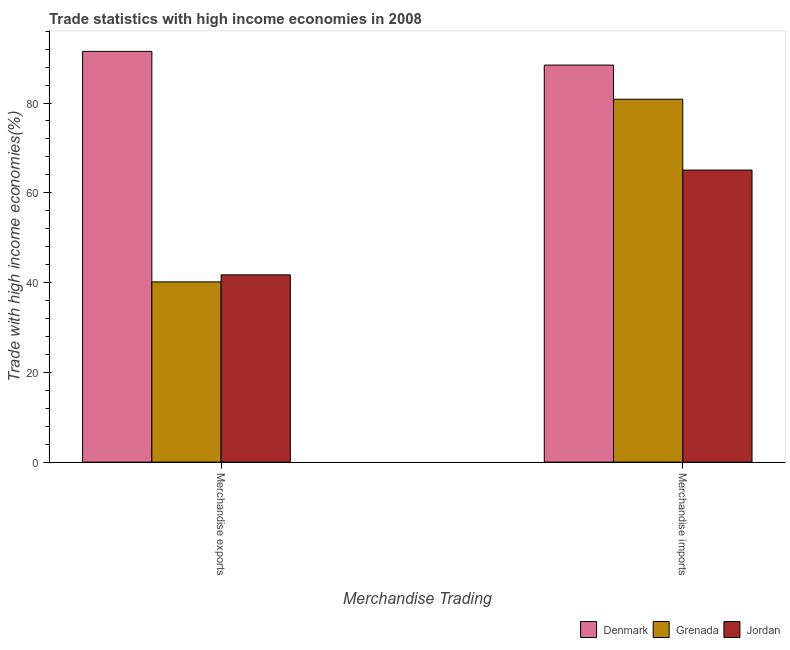Are the number of bars per tick equal to the number of legend labels?
Your answer should be compact. Yes. How many bars are there on the 2nd tick from the left?
Your response must be concise. 3. What is the merchandise imports in Jordan?
Offer a very short reply. 65.06. Across all countries, what is the maximum merchandise exports?
Provide a short and direct response. 91.5. Across all countries, what is the minimum merchandise imports?
Make the answer very short. 65.06. In which country was the merchandise imports minimum?
Keep it short and to the point. Jordan. What is the total merchandise exports in the graph?
Ensure brevity in your answer.  173.37. What is the difference between the merchandise imports in Grenada and that in Denmark?
Keep it short and to the point. -7.6. What is the difference between the merchandise exports in Denmark and the merchandise imports in Jordan?
Provide a short and direct response. 26.44. What is the average merchandise imports per country?
Your answer should be compact. 78.12. What is the difference between the merchandise exports and merchandise imports in Jordan?
Provide a short and direct response. -23.35. In how many countries, is the merchandise imports greater than 8 %?
Keep it short and to the point. 3. What is the ratio of the merchandise imports in Grenada to that in Jordan?
Keep it short and to the point. 1.24. In how many countries, is the merchandise imports greater than the average merchandise imports taken over all countries?
Your response must be concise. 2. What does the 3rd bar from the left in Merchandise imports represents?
Provide a succinct answer. Jordan. What does the 2nd bar from the right in Merchandise exports represents?
Your response must be concise. Grenada. What is the difference between two consecutive major ticks on the Y-axis?
Offer a terse response. 20. Does the graph contain any zero values?
Offer a terse response. No. How many legend labels are there?
Provide a short and direct response. 3. What is the title of the graph?
Offer a terse response. Trade statistics with high income economies in 2008. What is the label or title of the X-axis?
Provide a succinct answer. Merchandise Trading. What is the label or title of the Y-axis?
Keep it short and to the point. Trade with high income economies(%). What is the Trade with high income economies(%) in Denmark in Merchandise exports?
Offer a terse response. 91.5. What is the Trade with high income economies(%) of Grenada in Merchandise exports?
Provide a short and direct response. 40.15. What is the Trade with high income economies(%) of Jordan in Merchandise exports?
Provide a succinct answer. 41.71. What is the Trade with high income economies(%) of Denmark in Merchandise imports?
Your answer should be compact. 88.44. What is the Trade with high income economies(%) in Grenada in Merchandise imports?
Your answer should be compact. 80.84. What is the Trade with high income economies(%) of Jordan in Merchandise imports?
Make the answer very short. 65.06. Across all Merchandise Trading, what is the maximum Trade with high income economies(%) of Denmark?
Give a very brief answer. 91.5. Across all Merchandise Trading, what is the maximum Trade with high income economies(%) of Grenada?
Provide a short and direct response. 80.84. Across all Merchandise Trading, what is the maximum Trade with high income economies(%) in Jordan?
Ensure brevity in your answer.  65.06. Across all Merchandise Trading, what is the minimum Trade with high income economies(%) of Denmark?
Ensure brevity in your answer.  88.44. Across all Merchandise Trading, what is the minimum Trade with high income economies(%) in Grenada?
Give a very brief answer. 40.15. Across all Merchandise Trading, what is the minimum Trade with high income economies(%) of Jordan?
Provide a succinct answer. 41.71. What is the total Trade with high income economies(%) of Denmark in the graph?
Your answer should be compact. 179.95. What is the total Trade with high income economies(%) in Grenada in the graph?
Ensure brevity in your answer.  120.99. What is the total Trade with high income economies(%) in Jordan in the graph?
Offer a terse response. 106.77. What is the difference between the Trade with high income economies(%) of Denmark in Merchandise exports and that in Merchandise imports?
Ensure brevity in your answer.  3.06. What is the difference between the Trade with high income economies(%) of Grenada in Merchandise exports and that in Merchandise imports?
Your answer should be compact. -40.69. What is the difference between the Trade with high income economies(%) of Jordan in Merchandise exports and that in Merchandise imports?
Ensure brevity in your answer.  -23.35. What is the difference between the Trade with high income economies(%) of Denmark in Merchandise exports and the Trade with high income economies(%) of Grenada in Merchandise imports?
Make the answer very short. 10.66. What is the difference between the Trade with high income economies(%) in Denmark in Merchandise exports and the Trade with high income economies(%) in Jordan in Merchandise imports?
Your answer should be compact. 26.44. What is the difference between the Trade with high income economies(%) in Grenada in Merchandise exports and the Trade with high income economies(%) in Jordan in Merchandise imports?
Ensure brevity in your answer.  -24.91. What is the average Trade with high income economies(%) in Denmark per Merchandise Trading?
Keep it short and to the point. 89.97. What is the average Trade with high income economies(%) of Grenada per Merchandise Trading?
Provide a succinct answer. 60.5. What is the average Trade with high income economies(%) of Jordan per Merchandise Trading?
Give a very brief answer. 53.39. What is the difference between the Trade with high income economies(%) in Denmark and Trade with high income economies(%) in Grenada in Merchandise exports?
Your answer should be compact. 51.35. What is the difference between the Trade with high income economies(%) of Denmark and Trade with high income economies(%) of Jordan in Merchandise exports?
Offer a very short reply. 49.79. What is the difference between the Trade with high income economies(%) of Grenada and Trade with high income economies(%) of Jordan in Merchandise exports?
Ensure brevity in your answer.  -1.56. What is the difference between the Trade with high income economies(%) in Denmark and Trade with high income economies(%) in Grenada in Merchandise imports?
Give a very brief answer. 7.6. What is the difference between the Trade with high income economies(%) of Denmark and Trade with high income economies(%) of Jordan in Merchandise imports?
Your response must be concise. 23.38. What is the difference between the Trade with high income economies(%) in Grenada and Trade with high income economies(%) in Jordan in Merchandise imports?
Your response must be concise. 15.78. What is the ratio of the Trade with high income economies(%) of Denmark in Merchandise exports to that in Merchandise imports?
Your answer should be very brief. 1.03. What is the ratio of the Trade with high income economies(%) in Grenada in Merchandise exports to that in Merchandise imports?
Ensure brevity in your answer.  0.5. What is the ratio of the Trade with high income economies(%) of Jordan in Merchandise exports to that in Merchandise imports?
Provide a succinct answer. 0.64. What is the difference between the highest and the second highest Trade with high income economies(%) of Denmark?
Offer a terse response. 3.06. What is the difference between the highest and the second highest Trade with high income economies(%) in Grenada?
Offer a very short reply. 40.69. What is the difference between the highest and the second highest Trade with high income economies(%) of Jordan?
Keep it short and to the point. 23.35. What is the difference between the highest and the lowest Trade with high income economies(%) of Denmark?
Offer a terse response. 3.06. What is the difference between the highest and the lowest Trade with high income economies(%) in Grenada?
Your answer should be very brief. 40.69. What is the difference between the highest and the lowest Trade with high income economies(%) of Jordan?
Give a very brief answer. 23.35. 